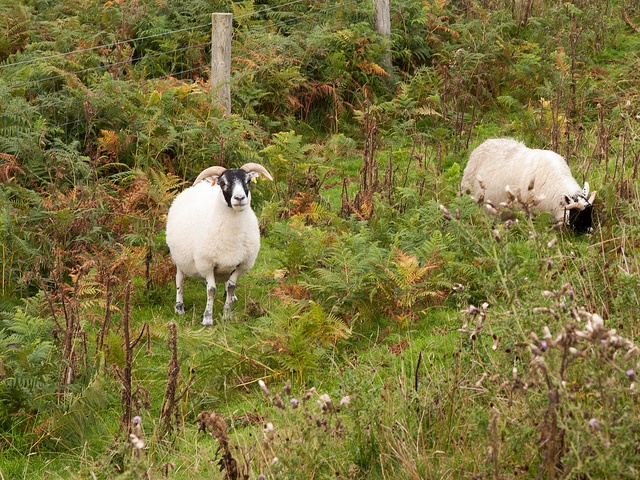Describe the objects in this image and their specific colors. I can see sheep in olive, lightgray, tan, and darkgray tones and sheep in olive, lightgray, and tan tones in this image. 